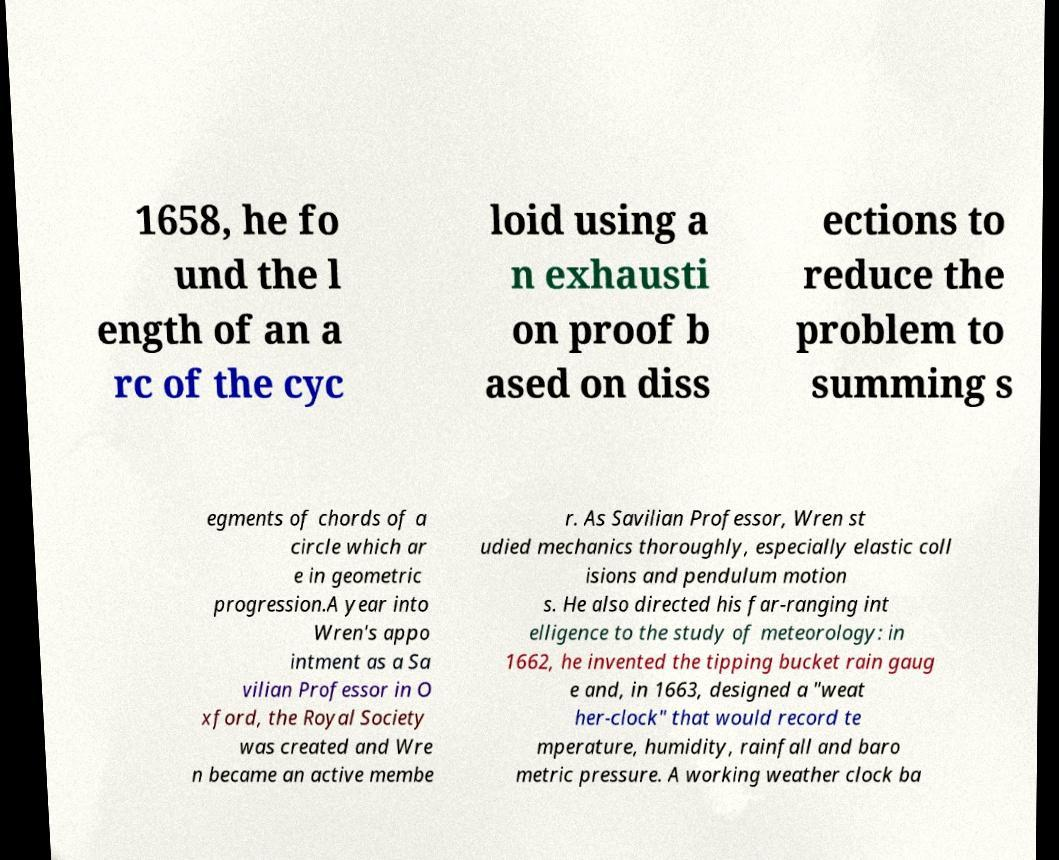Could you extract and type out the text from this image? 1658, he fo und the l ength of an a rc of the cyc loid using a n exhausti on proof b ased on diss ections to reduce the problem to summing s egments of chords of a circle which ar e in geometric progression.A year into Wren's appo intment as a Sa vilian Professor in O xford, the Royal Society was created and Wre n became an active membe r. As Savilian Professor, Wren st udied mechanics thoroughly, especially elastic coll isions and pendulum motion s. He also directed his far-ranging int elligence to the study of meteorology: in 1662, he invented the tipping bucket rain gaug e and, in 1663, designed a "weat her-clock" that would record te mperature, humidity, rainfall and baro metric pressure. A working weather clock ba 